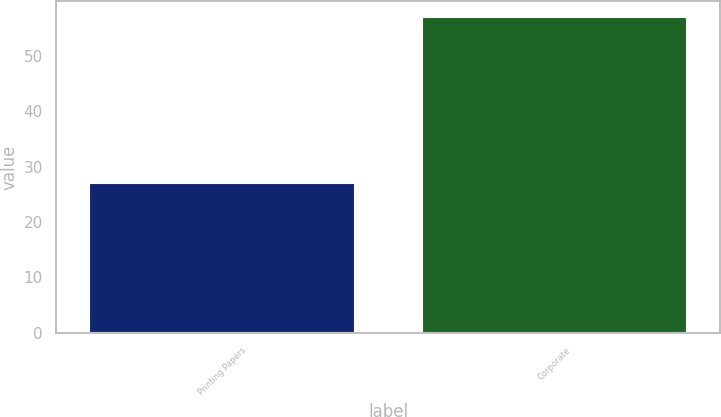Convert chart. <chart><loc_0><loc_0><loc_500><loc_500><bar_chart><fcel>Printing Papers<fcel>Corporate<nl><fcel>27<fcel>57<nl></chart> 